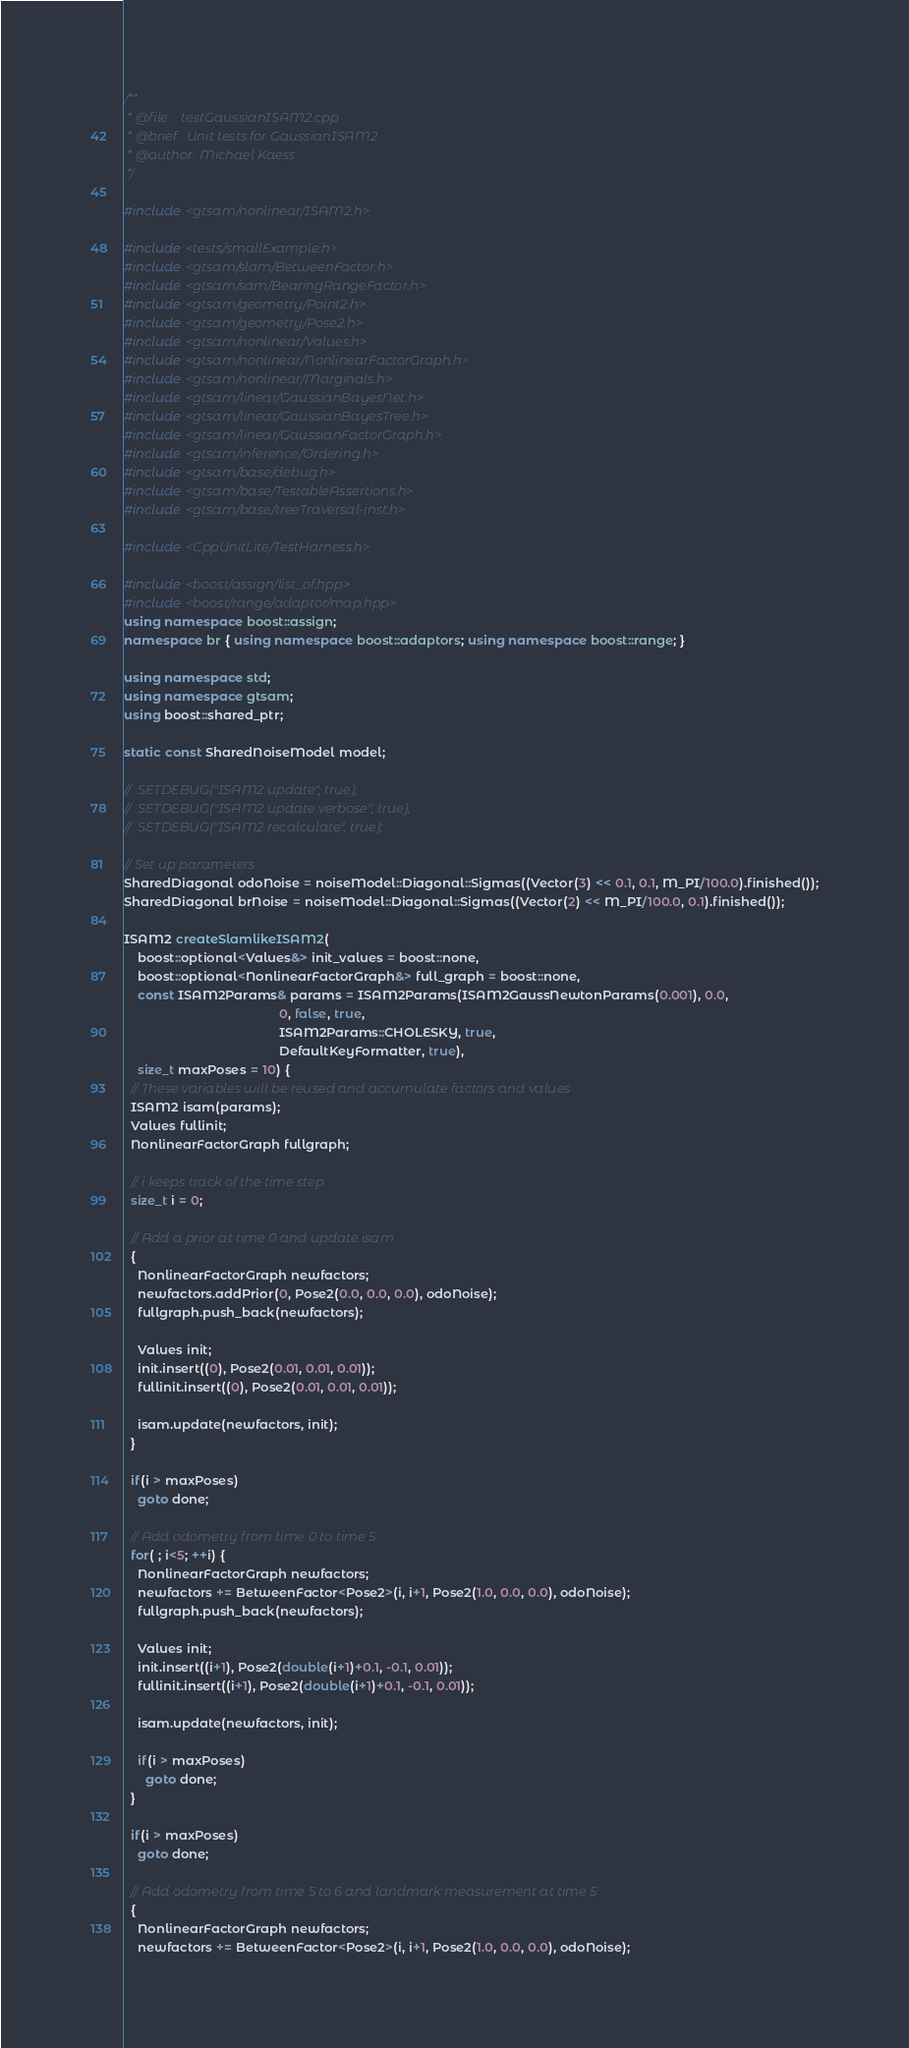<code> <loc_0><loc_0><loc_500><loc_500><_C++_>/**
 * @file    testGaussianISAM2.cpp
 * @brief   Unit tests for GaussianISAM2
 * @author  Michael Kaess
 */

#include <gtsam/nonlinear/ISAM2.h>

#include <tests/smallExample.h>
#include <gtsam/slam/BetweenFactor.h>
#include <gtsam/sam/BearingRangeFactor.h>
#include <gtsam/geometry/Point2.h>
#include <gtsam/geometry/Pose2.h>
#include <gtsam/nonlinear/Values.h>
#include <gtsam/nonlinear/NonlinearFactorGraph.h>
#include <gtsam/nonlinear/Marginals.h>
#include <gtsam/linear/GaussianBayesNet.h>
#include <gtsam/linear/GaussianBayesTree.h>
#include <gtsam/linear/GaussianFactorGraph.h>
#include <gtsam/inference/Ordering.h>
#include <gtsam/base/debug.h>
#include <gtsam/base/TestableAssertions.h>
#include <gtsam/base/treeTraversal-inst.h>

#include <CppUnitLite/TestHarness.h>

#include <boost/assign/list_of.hpp>
#include <boost/range/adaptor/map.hpp>
using namespace boost::assign;
namespace br { using namespace boost::adaptors; using namespace boost::range; }

using namespace std;
using namespace gtsam;
using boost::shared_ptr;

static const SharedNoiseModel model;

//  SETDEBUG("ISAM2 update", true);
//  SETDEBUG("ISAM2 update verbose", true);
//  SETDEBUG("ISAM2 recalculate", true);

// Set up parameters
SharedDiagonal odoNoise = noiseModel::Diagonal::Sigmas((Vector(3) << 0.1, 0.1, M_PI/100.0).finished());
SharedDiagonal brNoise = noiseModel::Diagonal::Sigmas((Vector(2) << M_PI/100.0, 0.1).finished());

ISAM2 createSlamlikeISAM2(
    boost::optional<Values&> init_values = boost::none,
    boost::optional<NonlinearFactorGraph&> full_graph = boost::none,
    const ISAM2Params& params = ISAM2Params(ISAM2GaussNewtonParams(0.001), 0.0,
                                            0, false, true,
                                            ISAM2Params::CHOLESKY, true,
                                            DefaultKeyFormatter, true),
    size_t maxPoses = 10) {
  // These variables will be reused and accumulate factors and values
  ISAM2 isam(params);
  Values fullinit;
  NonlinearFactorGraph fullgraph;

  // i keeps track of the time step
  size_t i = 0;

  // Add a prior at time 0 and update isam
  {
    NonlinearFactorGraph newfactors;
    newfactors.addPrior(0, Pose2(0.0, 0.0, 0.0), odoNoise);
    fullgraph.push_back(newfactors);

    Values init;
    init.insert((0), Pose2(0.01, 0.01, 0.01));
    fullinit.insert((0), Pose2(0.01, 0.01, 0.01));

    isam.update(newfactors, init);
  }

  if(i > maxPoses)
    goto done;

  // Add odometry from time 0 to time 5
  for( ; i<5; ++i) {
    NonlinearFactorGraph newfactors;
    newfactors += BetweenFactor<Pose2>(i, i+1, Pose2(1.0, 0.0, 0.0), odoNoise);
    fullgraph.push_back(newfactors);

    Values init;
    init.insert((i+1), Pose2(double(i+1)+0.1, -0.1, 0.01));
    fullinit.insert((i+1), Pose2(double(i+1)+0.1, -0.1, 0.01));

    isam.update(newfactors, init);

    if(i > maxPoses)
      goto done;
  }

  if(i > maxPoses)
    goto done;

  // Add odometry from time 5 to 6 and landmark measurement at time 5
  {
    NonlinearFactorGraph newfactors;
    newfactors += BetweenFactor<Pose2>(i, i+1, Pose2(1.0, 0.0, 0.0), odoNoise);</code> 